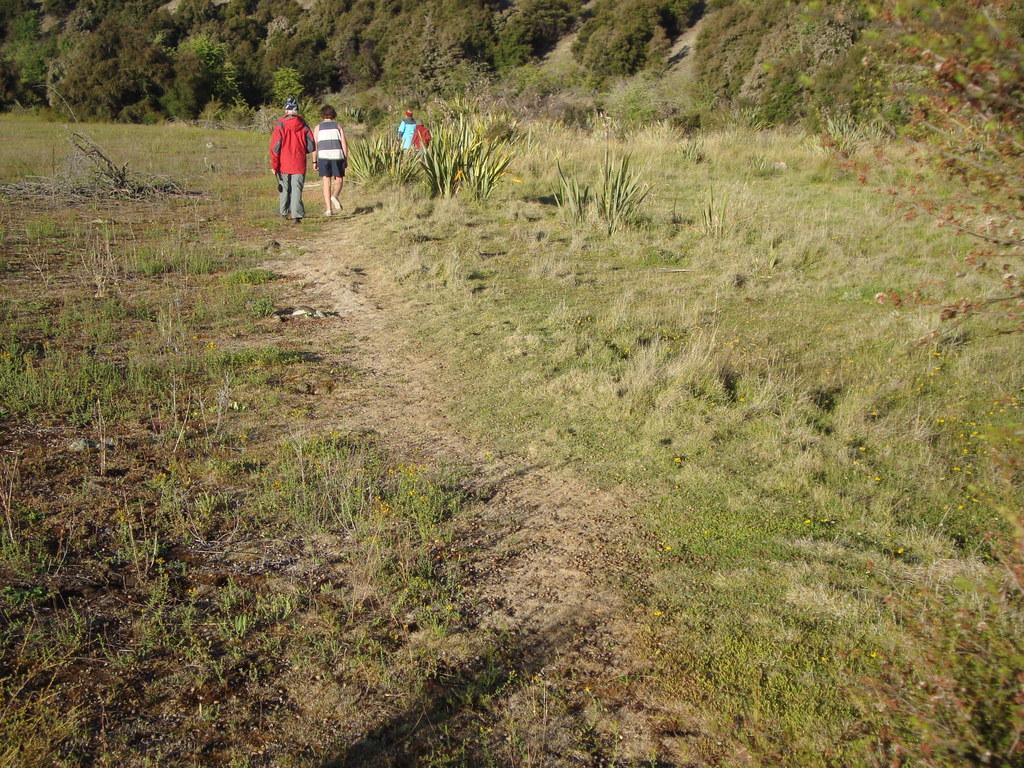How many people are present in the image? There are three people in the image. What are the people doing in the image? The people are walking on the ground in the image. What type of vegetation can be seen in the image? There are plants, trees, and grass in the image. What color are the eyes of the person in the middle of the image? There is no information about the color of anyone's eyes in the image, as the facts provided do not mention anything about the people's eyes. 